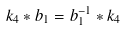Convert formula to latex. <formula><loc_0><loc_0><loc_500><loc_500>k _ { 4 } * b _ { 1 } = b _ { 1 } ^ { - 1 } * k _ { 4 } \</formula> 